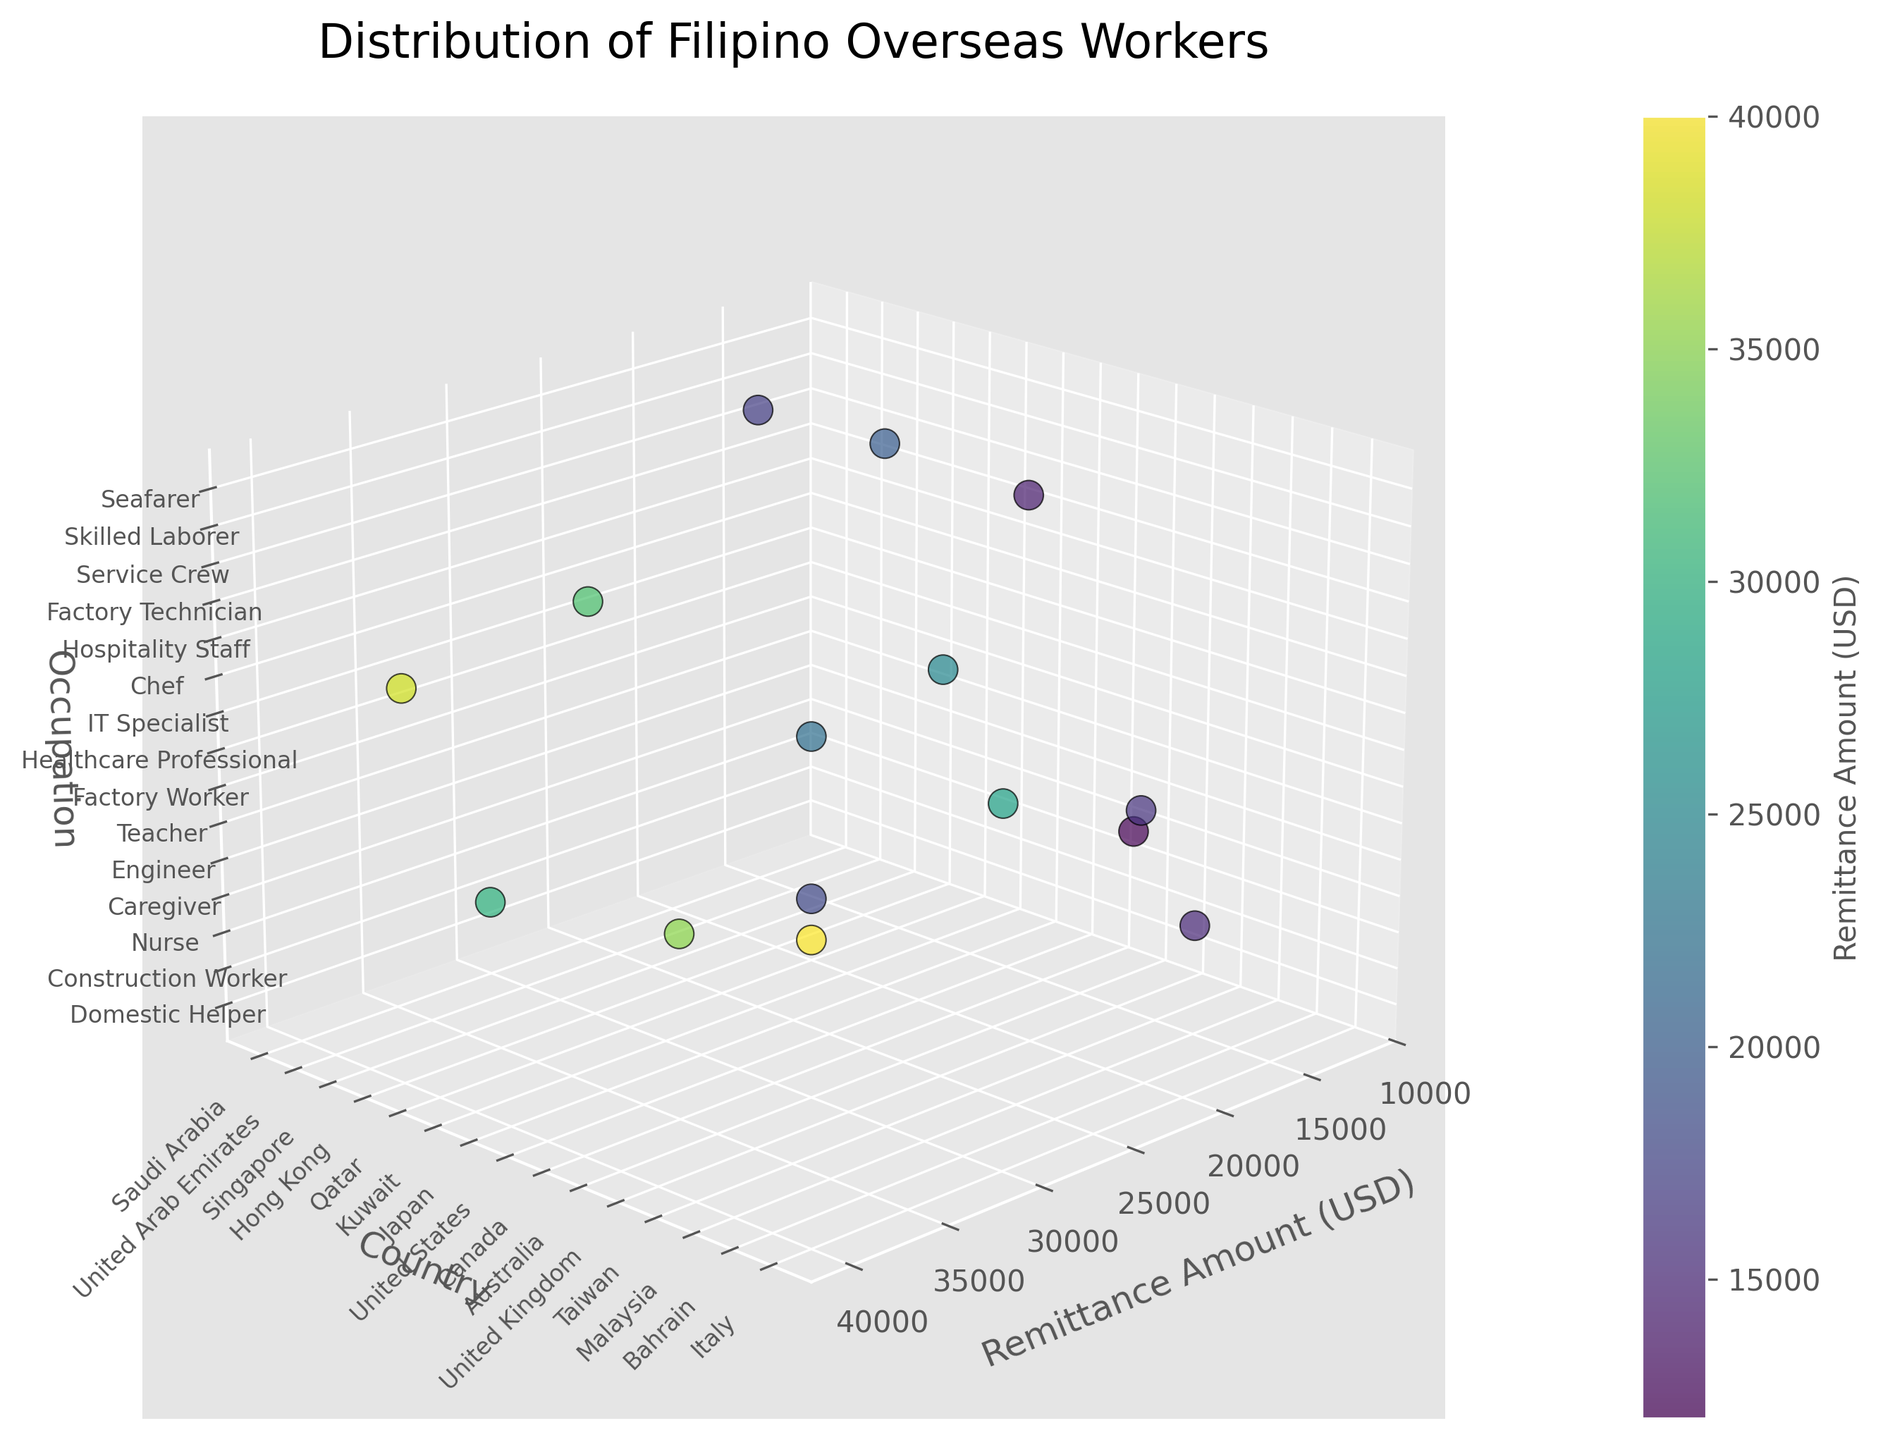What is the title of the figure? The title is usually displayed at the top of the plot. By observing the top part of the figure, we can see the title.
Answer: Distribution of Filipino Overseas Workers What color scale is used to represent the remittance amounts? The color scale is indicated by both the scatter plot colors and the color bar adjacent to the plot. The color bar shows a gradient from one color to another, representing different values.
Answer: Viridis Which country has the highest remittance amount? Identify the highest point on the x-axis (Remittance Amount) and then trace it to its corresponding y-label (Country).
Answer: United States Which occupation has the highest remittance amount? Identify the highest point on the x-axis, then trace it to its corresponding z-label (Occupation).
Answer: Healthcare Professional How many unique occupations are represented in the plot? The z-axis contains unique tick labels representing occupations. By counting these ticks, we can find the number of unique occupations.
Answer: 14 Which country is associated with engineering occupation and what is the remittance amount? Find the 'Engineer' occupation on the z-axis, then trace its corresponding point to the y-axis (Country) and x-axis (Remittance Amount).
Answer: Qatar, 35000 Which occupation is common in Hong Kong and what is the remittance amount? Find 'Hong Kong' on the y-axis, then trace its corresponding point to the z-axis (Occupation) and the x-axis (Remittance Amount).
Answer: Caregiver, 18000 How does the remittance amount for a Seafarer in Italy compare to a Nurse in Singapore? Identify the points for Seafarer in Italy and Nurse in Singapore on the plot, then compare their x-axis values (Remittance Amounts).
Answer: Seafarer 32000, Nurse 25000, Seafarer is higher What remittance amount does a Construction Worker in United Arab Emirates send? Locate 'United Arab Emirates' on the y-axis, trace it to the 'Construction Worker' on the z-axis, and then find its corresponding x-axis value.
Answer: 15000 Which country has the lowest remittance amount, and what is the occupation associated with it? Identify the lowest point on the x-axis (Remittance Amount), then trace it to its corresponding y-label (Country) and z-label (Occupation).
Answer: Malaysia, Service Crew 